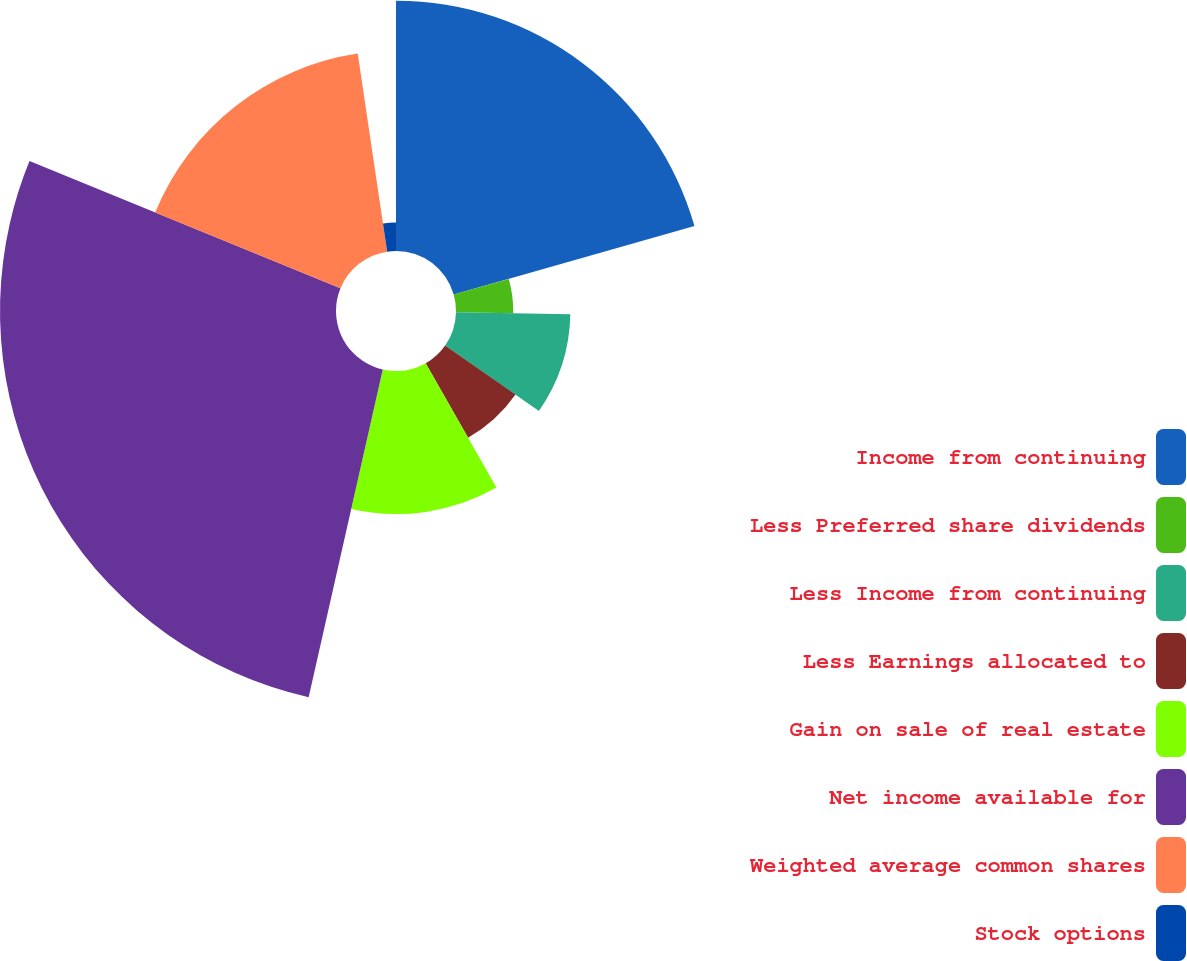Convert chart to OTSL. <chart><loc_0><loc_0><loc_500><loc_500><pie_chart><fcel>Income from continuing<fcel>Less Preferred share dividends<fcel>Less Income from continuing<fcel>Less Earnings allocated to<fcel>Gain on sale of real estate<fcel>Net income available for<fcel>Weighted average common shares<fcel>Stock options<nl><fcel>20.59%<fcel>4.71%<fcel>9.41%<fcel>7.06%<fcel>11.77%<fcel>27.64%<fcel>16.47%<fcel>2.35%<nl></chart> 